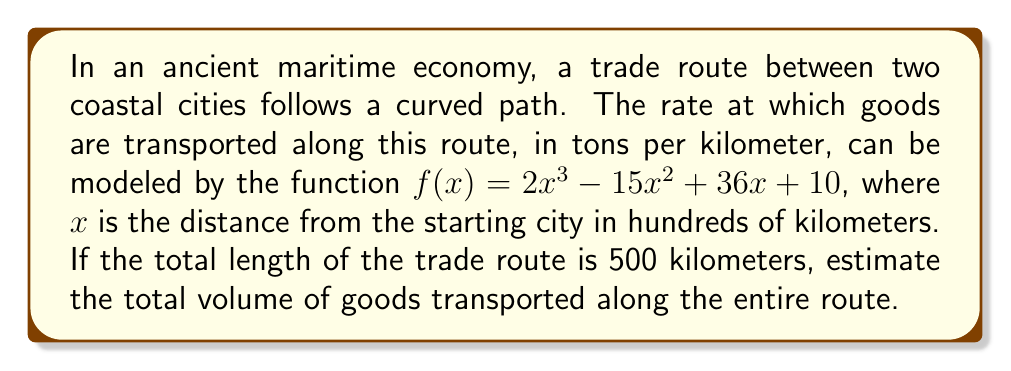Show me your answer to this math problem. To solve this problem, we need to integrate the given function over the entire length of the trade route. Let's break it down step by step:

1) First, we need to set up our integral. The function $f(x)$ gives us the rate of goods transported in tons per kilometer. To find the total volume, we need to integrate this function over the entire distance:

   $$\int_0^5 f(x) dx$$

   Note that we use 0 to 5 as our limits because the distance is given in hundreds of kilometers, and the total distance is 500 km.

2) Now, let's substitute our function and set up the integral:

   $$\int_0^5 (2x^3 - 15x^2 + 36x + 10) dx$$

3) We can integrate this term by term:

   $$\left[\frac{1}{2}x^4 - 5x^3 + 18x^2 + 10x\right]_0^5$$

4) Now, let's evaluate this at the upper and lower bounds:

   At x = 5:
   $$\frac{1}{2}(5^4) - 5(5^3) + 18(5^2) + 10(5) = 312.5 - 625 + 450 + 50 = 187.5$$

   At x = 0:
   $$\frac{1}{2}(0^4) - 5(0^3) + 18(0^2) + 10(0) = 0$$

5) Subtracting the lower bound from the upper bound:

   $$187.5 - 0 = 187.5$$

6) Remember that this result is in hundreds of tons, as our original function was in tons per hundred kilometers. So we need to multiply by 100 to get the final result in tons.

   $$187.5 * 100 = 18,750$$

Therefore, the estimated total volume of goods transported along the entire route is 18,750 tons.
Answer: 18,750 tons 